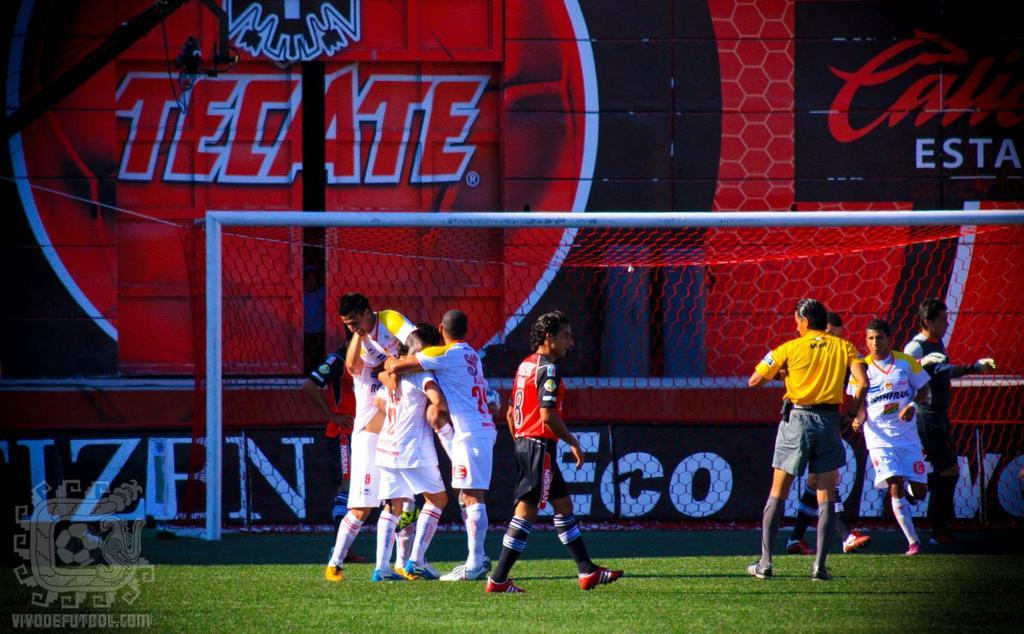Who or what can be seen in the image? There are people in the image. Where are the people located? The people are on the grass. What else is visible in the image besides the people? There is a net and a banner visible in the image. What type of car is parked on the grass in the image? There is no car present in the image; it features people on the grass with a net and a banner. 